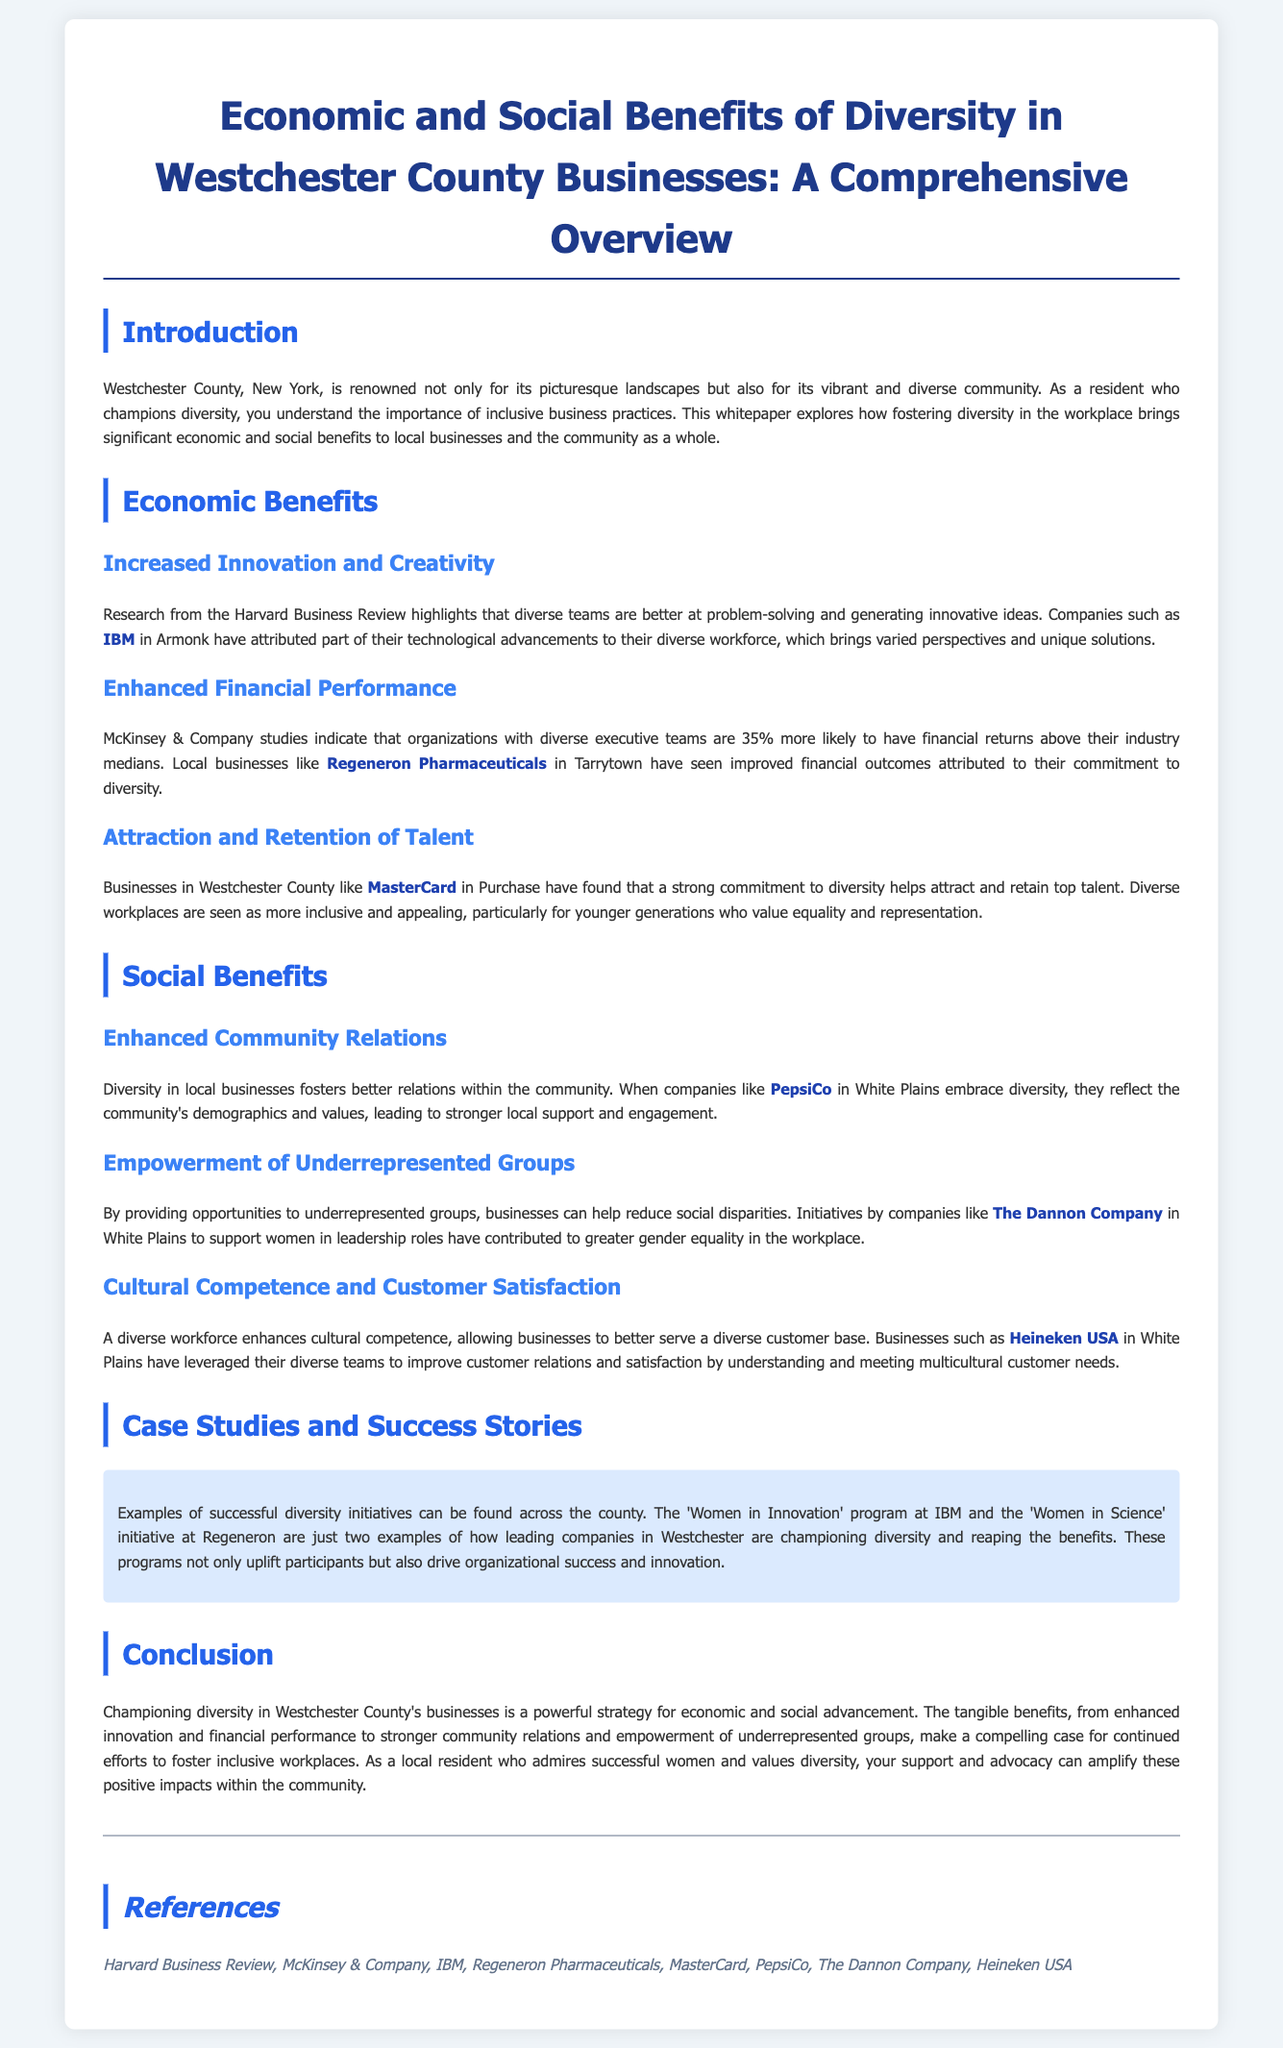What is the title of the whitepaper? The title is the main heading that summarizes the document's content, which is "Economic and Social Benefits of Diversity in Westchester County Businesses: A Comprehensive Overview".
Answer: Economic and Social Benefits of Diversity in Westchester County Businesses: A Comprehensive Overview Which company in Armonk is mentioned as benefiting from a diverse workforce? The document specifies that IBM, located in Armonk, has attributed technological advancements to their diverse workforce.
Answer: IBM What percentage more likely are organizations with diverse executive teams to have financial returns above their industry medians? The document states that organizations with diverse executive teams are 35% more likely to have better financial returns.
Answer: 35% What type of program does IBM have that supports women? The document highlights that IBM has a "Women in Innovation" program that promotes diversity.
Answer: Women in Innovation Which company's initiative has contributed to greater gender equality in the workplace? The Dannon Company’s initiatives support women in leadership roles, which contribute to gender equality as mentioned in the document.
Answer: The Dannon Company What city is mentioned alongside Regeneron Pharmaceuticals? The document refers to Regeneron Pharmaceuticals being located in Tarrytown.
Answer: Tarrytown Which company is known for its 'Women in Science' initiative? The document specifies that Regeneron is known for its "Women in Science" initiative.
Answer: Regeneron What do diverse workplaces help attract according to the whitepaper? The whitepaper states that a strong commitment to diversity helps attract and retain top talent.
Answer: Top talent What is one social benefit of diversity mentioned in the document? The document mentions "Enhanced Community Relations" as a social benefit fostered by diversity in local businesses.
Answer: Enhanced Community Relations 